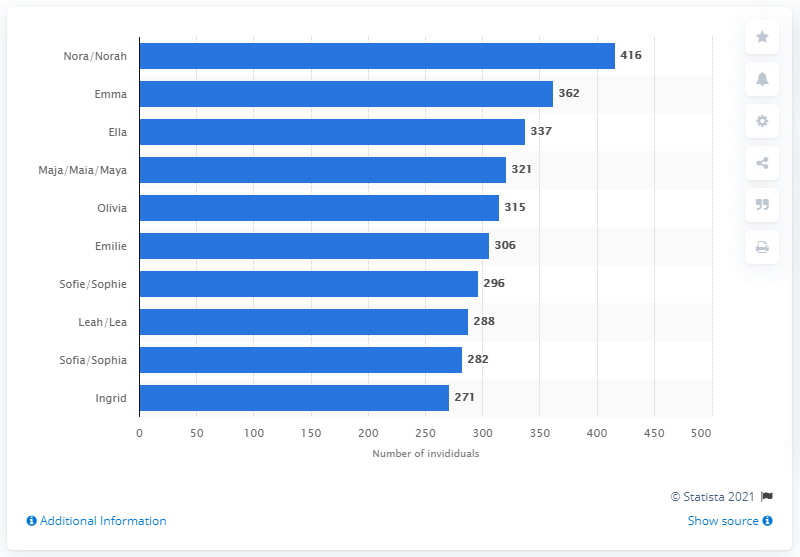Give some essential details in this illustration. In 2020, a total of 416 newborns in Norway were given the names Nora or Norah. Ten baby names have been considered. Leah/Lea has a difference of 6 compared to Sofia/Sophia. 